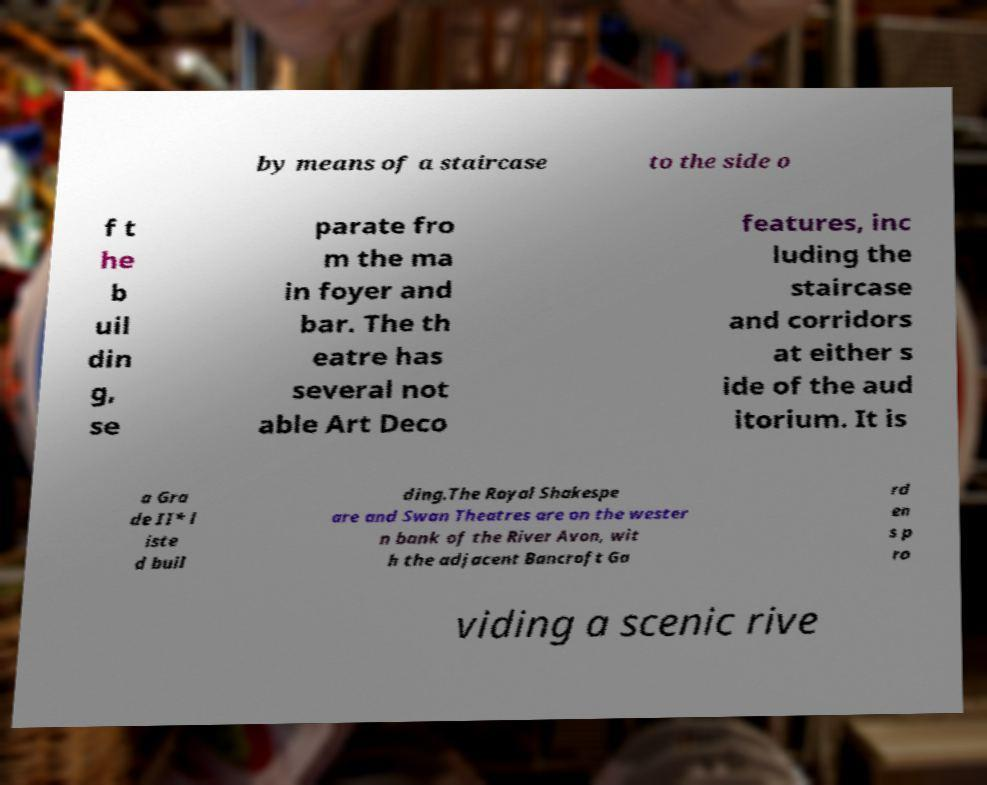There's text embedded in this image that I need extracted. Can you transcribe it verbatim? by means of a staircase to the side o f t he b uil din g, se parate fro m the ma in foyer and bar. The th eatre has several not able Art Deco features, inc luding the staircase and corridors at either s ide of the aud itorium. It is a Gra de II* l iste d buil ding.The Royal Shakespe are and Swan Theatres are on the wester n bank of the River Avon, wit h the adjacent Bancroft Ga rd en s p ro viding a scenic rive 